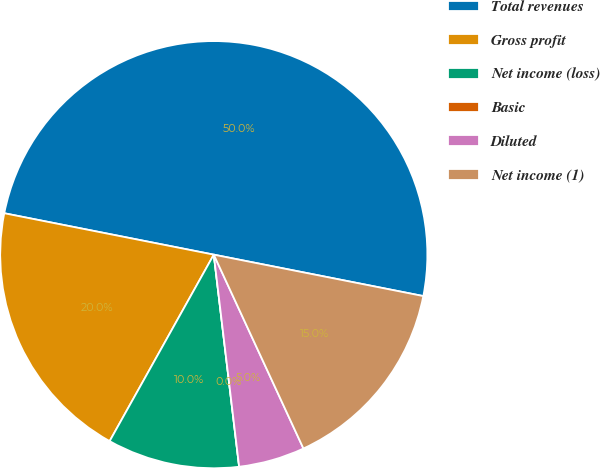Convert chart. <chart><loc_0><loc_0><loc_500><loc_500><pie_chart><fcel>Total revenues<fcel>Gross profit<fcel>Net income (loss)<fcel>Basic<fcel>Diluted<fcel>Net income (1)<nl><fcel>50.0%<fcel>20.0%<fcel>10.0%<fcel>0.0%<fcel>5.0%<fcel>15.0%<nl></chart> 